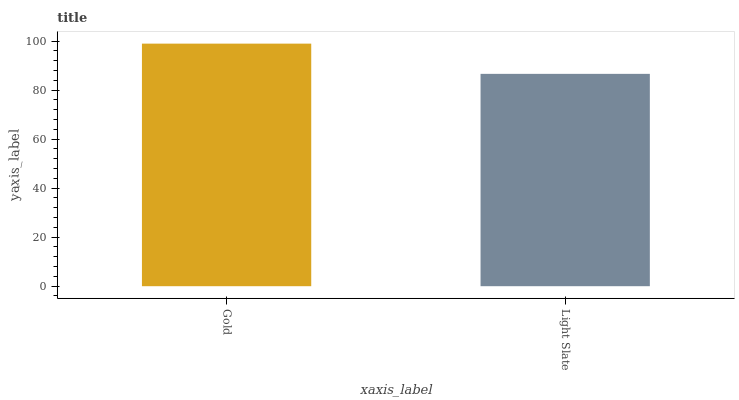Is Light Slate the minimum?
Answer yes or no. Yes. Is Gold the maximum?
Answer yes or no. Yes. Is Light Slate the maximum?
Answer yes or no. No. Is Gold greater than Light Slate?
Answer yes or no. Yes. Is Light Slate less than Gold?
Answer yes or no. Yes. Is Light Slate greater than Gold?
Answer yes or no. No. Is Gold less than Light Slate?
Answer yes or no. No. Is Gold the high median?
Answer yes or no. Yes. Is Light Slate the low median?
Answer yes or no. Yes. Is Light Slate the high median?
Answer yes or no. No. Is Gold the low median?
Answer yes or no. No. 